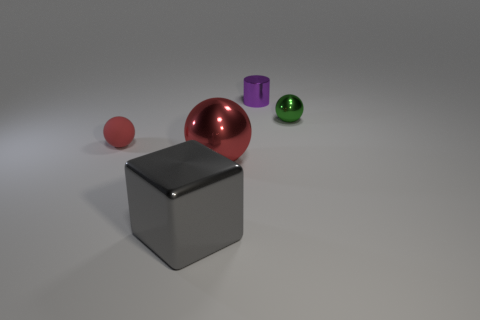Subtract all large red metal spheres. How many spheres are left? 2 Subtract all yellow blocks. How many red spheres are left? 2 Subtract all cylinders. How many objects are left? 4 Add 5 large metal spheres. How many objects exist? 10 Subtract all green balls. How many balls are left? 2 Subtract 1 balls. How many balls are left? 2 Add 2 big red shiny things. How many big red shiny things are left? 3 Add 5 small green shiny balls. How many small green shiny balls exist? 6 Subtract 1 gray cubes. How many objects are left? 4 Subtract all blue balls. Subtract all green cylinders. How many balls are left? 3 